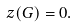<formula> <loc_0><loc_0><loc_500><loc_500>z ( G ) = 0 .</formula> 